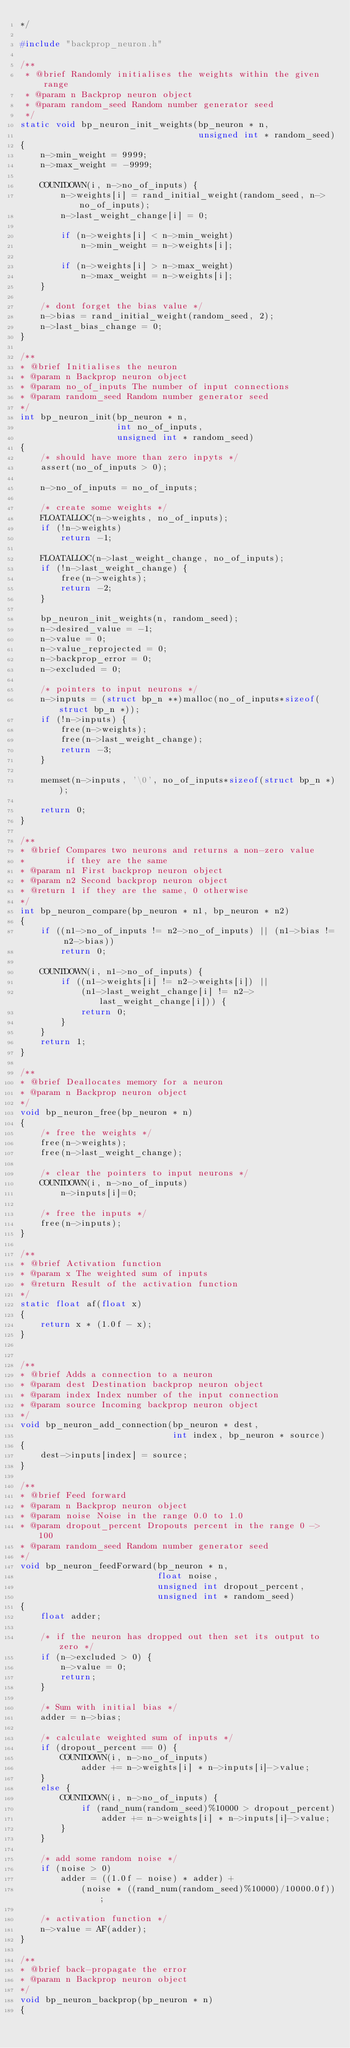Convert code to text. <code><loc_0><loc_0><loc_500><loc_500><_C_>*/

#include "backprop_neuron.h"

/**
 * @brief Randomly initialises the weights within the given range
 * @param n Backprop neuron object
 * @param random_seed Random number generator seed
 */
static void bp_neuron_init_weights(bp_neuron * n,
                                   unsigned int * random_seed)
{
    n->min_weight = 9999;
    n->max_weight = -9999;

    COUNTDOWN(i, n->no_of_inputs) {
        n->weights[i] = rand_initial_weight(random_seed, n->no_of_inputs);
        n->last_weight_change[i] = 0;

        if (n->weights[i] < n->min_weight)
            n->min_weight = n->weights[i];

        if (n->weights[i] > n->max_weight)
            n->max_weight = n->weights[i];
    }

    /* dont forget the bias value */
    n->bias = rand_initial_weight(random_seed, 2);
    n->last_bias_change = 0;
}

/**
* @brief Initialises the neuron
* @param n Backprop neuron object
* @param no_of_inputs The number of input connections
* @param random_seed Random number generator seed
*/
int bp_neuron_init(bp_neuron * n,
                   int no_of_inputs,
                   unsigned int * random_seed)
{
    /* should have more than zero inpyts */
    assert(no_of_inputs > 0);

    n->no_of_inputs = no_of_inputs;

    /* create some weights */
    FLOATALLOC(n->weights, no_of_inputs);
    if (!n->weights)
        return -1;

    FLOATALLOC(n->last_weight_change, no_of_inputs);
    if (!n->last_weight_change) {
        free(n->weights);
        return -2;
    }

    bp_neuron_init_weights(n, random_seed);
    n->desired_value = -1;
    n->value = 0;
    n->value_reprojected = 0;
    n->backprop_error = 0;
    n->excluded = 0;

    /* pointers to input neurons */
    n->inputs = (struct bp_n **)malloc(no_of_inputs*sizeof(struct bp_n *));
    if (!n->inputs) {
        free(n->weights);
        free(n->last_weight_change);
        return -3;
    }

    memset(n->inputs, '\0', no_of_inputs*sizeof(struct bp_n *));

    return 0;
}

/**
* @brief Compares two neurons and returns a non-zero value
*        if they are the same
* @param n1 First backprop neuron object
* @param n2 Second backprop neuron object
* @return 1 if they are the same, 0 otherwise
*/
int bp_neuron_compare(bp_neuron * n1, bp_neuron * n2)
{
    if ((n1->no_of_inputs != n2->no_of_inputs) || (n1->bias != n2->bias))
        return 0;

    COUNTDOWN(i, n1->no_of_inputs) {
        if ((n1->weights[i] != n2->weights[i]) ||
            (n1->last_weight_change[i] != n2->last_weight_change[i])) {
            return 0;
        }
    }
    return 1;
}

/**
* @brief Deallocates memory for a neuron
* @param n Backprop neuron object
*/
void bp_neuron_free(bp_neuron * n)
{
    /* free the weights */
    free(n->weights);
    free(n->last_weight_change);

    /* clear the pointers to input neurons */
    COUNTDOWN(i, n->no_of_inputs)
        n->inputs[i]=0;

    /* free the inputs */
    free(n->inputs);
}

/**
* @brief Activation function
* @param x The weighted sum of inputs
* @return Result of the activation function
*/
static float af(float x)
{
    return x * (1.0f - x);
}


/**
* @brief Adds a connection to a neuron
* @param dest Destination backprop neuron object
* @param index Index number of the input connection
* @param source Incoming backprop neuron object
*/
void bp_neuron_add_connection(bp_neuron * dest,
                              int index, bp_neuron * source)
{
    dest->inputs[index] = source;
}

/**
* @brief Feed forward
* @param n Backprop neuron object
* @param noise Noise in the range 0.0 to 1.0
* @param dropout_percent Dropouts percent in the range 0 -> 100
* @param random_seed Random number generator seed
*/
void bp_neuron_feedForward(bp_neuron * n,
                           float noise,
                           unsigned int dropout_percent,
                           unsigned int * random_seed)
{
    float adder;

    /* if the neuron has dropped out then set its output to zero */
    if (n->excluded > 0) {
        n->value = 0;
        return;
    }

    /* Sum with initial bias */
    adder = n->bias;

    /* calculate weighted sum of inputs */
    if (dropout_percent == 0) {
        COUNTDOWN(i, n->no_of_inputs)
            adder += n->weights[i] * n->inputs[i]->value;
    }
    else {
        COUNTDOWN(i, n->no_of_inputs) {
            if (rand_num(random_seed)%10000 > dropout_percent)
                adder += n->weights[i] * n->inputs[i]->value;
        }
    }

    /* add some random noise */
    if (noise > 0)
        adder = ((1.0f - noise) * adder) +
            (noise * ((rand_num(random_seed)%10000)/10000.0f));

    /* activation function */
    n->value = AF(adder);
}

/**
* @brief back-propagate the error
* @param n Backprop neuron object
*/
void bp_neuron_backprop(bp_neuron * n)
{</code> 